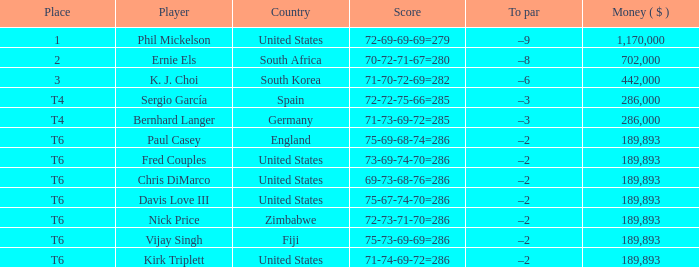What is the amount of money (in dollars) when the position is t6 and the player is chris dimarco? 189893.0. 